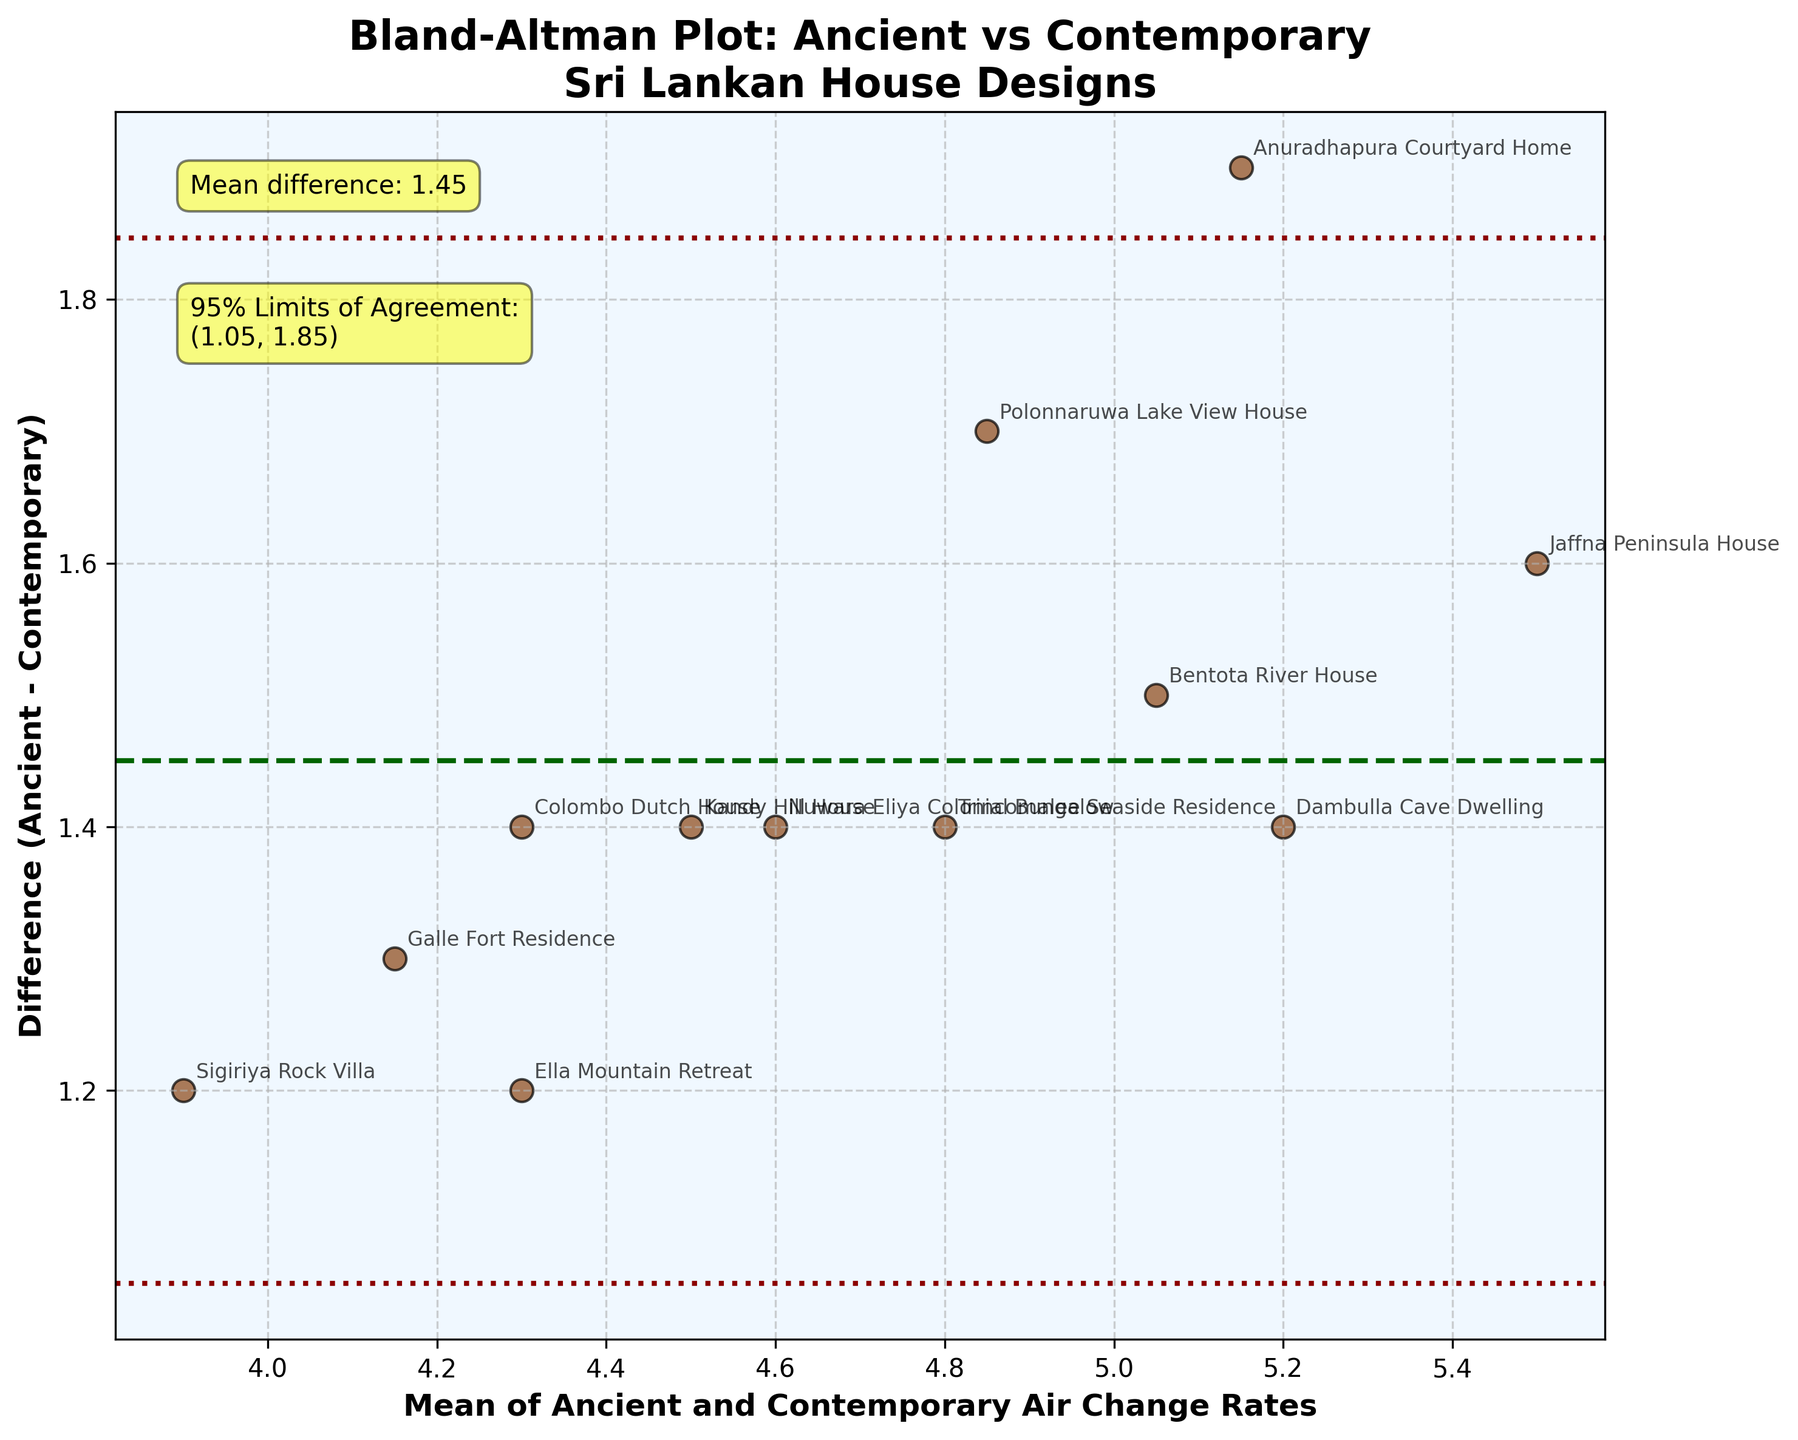What is the title of the plot? The title is located at the top center of the plot, and it describes what the plot is about.
Answer: Bland-Altman Plot: Ancient vs Contemporary Sri Lankan House Designs What does the x-axis represent? The x-axis represents the mean of the air change rates from ancient and contemporary house designs. This is typically denoted in the label for the x-axis.
Answer: Mean of Ancient and Contemporary Air Change Rates What is the mean difference of air change rates between ancient and contemporary house designs? The mean difference is indicated by a horizontal dashed green line, and an annotation shows the exact value of the mean difference.
Answer: Approximately 1.60 How many house designs are represented in the plot? By counting the number of data points (scatters) on the plot or by referencing each house name annotated near the points, one can determine the total number of house designs.
Answer: 12 What are the 95% limits of agreement? The 95% limits of agreement are represented by two horizontal lines, one above and one below the mean difference line, and their exact values are shown in an annotation on the plot.
Answer: Approximately 0.77 and 2.43 Which house design shows the largest difference in air change rates? By examining the plot, the point furthest away from the horizontal mean difference line along the y-axis indicates the largest difference.
Answer: Jaffna Peninsula House What is the air change rate difference for the 'Kandy Hill House'? By locating the annotation for 'Kandy Hill House' on the plot, we observe its position relative to the mean difference line.
Answer: Approximately 1.4 How is the air change rate difference generally trending? By observing the scatter of data points around the mean difference line, we can describe the overall trend of the differences in air change rates.
Answer: Mostly positive, indicating ancient designs typically have higher rates Which house shows the smallest mean air change rate between ancient and contemporary designs? By identifying the point closest to the left on the x-axis and checking its annotation for the house name.
Answer: Sigiriya Rock Villa Are any of the house designs outside the 95% limits of agreement? Checking if any data points lie beyond the dotted red lines representing the 95% limits of agreement will provide this information.
Answer: No 